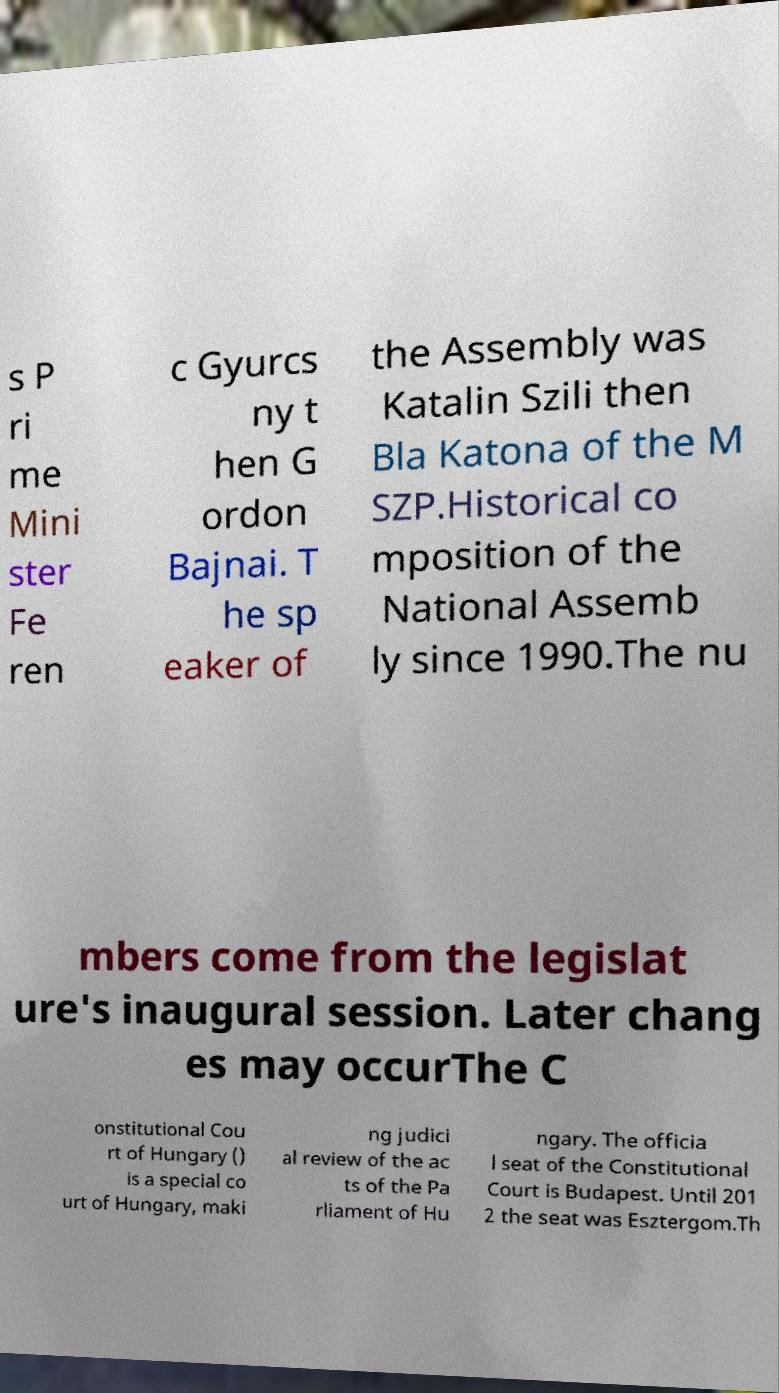Please read and relay the text visible in this image. What does it say? s P ri me Mini ster Fe ren c Gyurcs ny t hen G ordon Bajnai. T he sp eaker of the Assembly was Katalin Szili then Bla Katona of the M SZP.Historical co mposition of the National Assemb ly since 1990.The nu mbers come from the legislat ure's inaugural session. Later chang es may occurThe C onstitutional Cou rt of Hungary () is a special co urt of Hungary, maki ng judici al review of the ac ts of the Pa rliament of Hu ngary. The officia l seat of the Constitutional Court is Budapest. Until 201 2 the seat was Esztergom.Th 